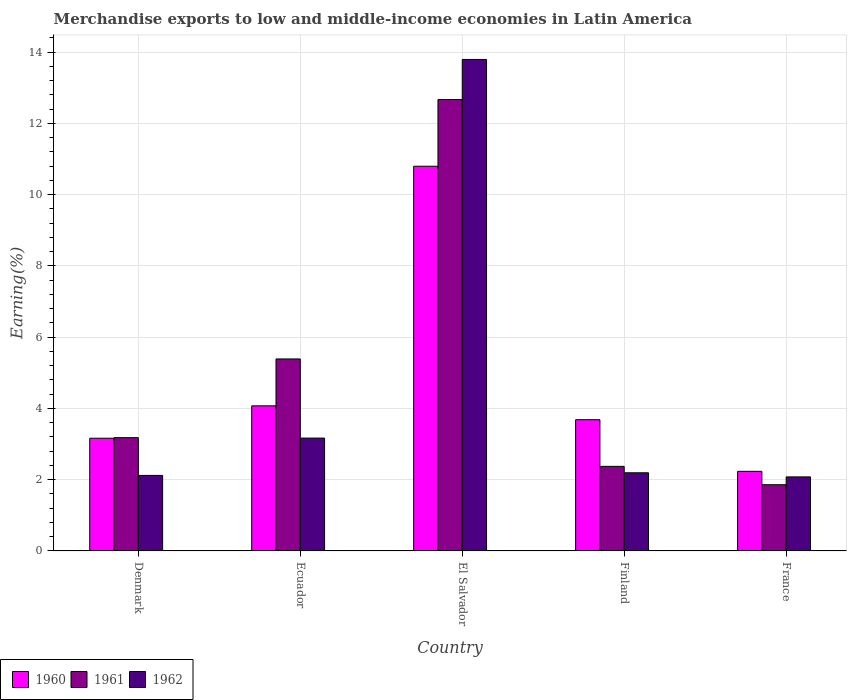Are the number of bars per tick equal to the number of legend labels?
Offer a terse response. Yes. Are the number of bars on each tick of the X-axis equal?
Your response must be concise. Yes. How many bars are there on the 1st tick from the right?
Provide a short and direct response. 3. What is the label of the 3rd group of bars from the left?
Your answer should be compact. El Salvador. What is the percentage of amount earned from merchandise exports in 1962 in France?
Provide a succinct answer. 2.08. Across all countries, what is the maximum percentage of amount earned from merchandise exports in 1961?
Ensure brevity in your answer.  12.67. Across all countries, what is the minimum percentage of amount earned from merchandise exports in 1960?
Make the answer very short. 2.23. In which country was the percentage of amount earned from merchandise exports in 1961 maximum?
Offer a very short reply. El Salvador. In which country was the percentage of amount earned from merchandise exports in 1960 minimum?
Your answer should be very brief. France. What is the total percentage of amount earned from merchandise exports in 1961 in the graph?
Ensure brevity in your answer.  25.47. What is the difference between the percentage of amount earned from merchandise exports in 1961 in Denmark and that in France?
Provide a succinct answer. 1.32. What is the difference between the percentage of amount earned from merchandise exports in 1960 in Finland and the percentage of amount earned from merchandise exports in 1961 in El Salvador?
Offer a very short reply. -8.98. What is the average percentage of amount earned from merchandise exports in 1960 per country?
Make the answer very short. 4.79. What is the difference between the percentage of amount earned from merchandise exports of/in 1960 and percentage of amount earned from merchandise exports of/in 1961 in Denmark?
Provide a short and direct response. -0.02. What is the ratio of the percentage of amount earned from merchandise exports in 1960 in Denmark to that in Ecuador?
Your answer should be compact. 0.78. Is the difference between the percentage of amount earned from merchandise exports in 1960 in El Salvador and Finland greater than the difference between the percentage of amount earned from merchandise exports in 1961 in El Salvador and Finland?
Offer a very short reply. No. What is the difference between the highest and the second highest percentage of amount earned from merchandise exports in 1962?
Your response must be concise. -0.97. What is the difference between the highest and the lowest percentage of amount earned from merchandise exports in 1962?
Provide a short and direct response. 11.71. Is it the case that in every country, the sum of the percentage of amount earned from merchandise exports in 1962 and percentage of amount earned from merchandise exports in 1961 is greater than the percentage of amount earned from merchandise exports in 1960?
Make the answer very short. Yes. How many bars are there?
Provide a short and direct response. 15. Are all the bars in the graph horizontal?
Your response must be concise. No. How many countries are there in the graph?
Keep it short and to the point. 5. Where does the legend appear in the graph?
Offer a very short reply. Bottom left. How many legend labels are there?
Your answer should be compact. 3. How are the legend labels stacked?
Keep it short and to the point. Horizontal. What is the title of the graph?
Make the answer very short. Merchandise exports to low and middle-income economies in Latin America. What is the label or title of the X-axis?
Provide a short and direct response. Country. What is the label or title of the Y-axis?
Make the answer very short. Earning(%). What is the Earning(%) in 1960 in Denmark?
Your answer should be very brief. 3.16. What is the Earning(%) of 1961 in Denmark?
Provide a succinct answer. 3.18. What is the Earning(%) in 1962 in Denmark?
Give a very brief answer. 2.12. What is the Earning(%) in 1960 in Ecuador?
Provide a succinct answer. 4.07. What is the Earning(%) in 1961 in Ecuador?
Provide a short and direct response. 5.39. What is the Earning(%) in 1962 in Ecuador?
Provide a succinct answer. 3.17. What is the Earning(%) in 1960 in El Salvador?
Offer a terse response. 10.8. What is the Earning(%) of 1961 in El Salvador?
Offer a terse response. 12.67. What is the Earning(%) of 1962 in El Salvador?
Provide a short and direct response. 13.79. What is the Earning(%) in 1960 in Finland?
Give a very brief answer. 3.68. What is the Earning(%) in 1961 in Finland?
Provide a succinct answer. 2.37. What is the Earning(%) in 1962 in Finland?
Make the answer very short. 2.19. What is the Earning(%) in 1960 in France?
Provide a succinct answer. 2.23. What is the Earning(%) of 1961 in France?
Offer a terse response. 1.86. What is the Earning(%) in 1962 in France?
Your answer should be compact. 2.08. Across all countries, what is the maximum Earning(%) of 1960?
Provide a short and direct response. 10.8. Across all countries, what is the maximum Earning(%) in 1961?
Your answer should be very brief. 12.67. Across all countries, what is the maximum Earning(%) of 1962?
Provide a succinct answer. 13.79. Across all countries, what is the minimum Earning(%) of 1960?
Ensure brevity in your answer.  2.23. Across all countries, what is the minimum Earning(%) in 1961?
Your response must be concise. 1.86. Across all countries, what is the minimum Earning(%) of 1962?
Keep it short and to the point. 2.08. What is the total Earning(%) of 1960 in the graph?
Make the answer very short. 23.95. What is the total Earning(%) of 1961 in the graph?
Your answer should be compact. 25.47. What is the total Earning(%) in 1962 in the graph?
Keep it short and to the point. 23.35. What is the difference between the Earning(%) of 1960 in Denmark and that in Ecuador?
Ensure brevity in your answer.  -0.91. What is the difference between the Earning(%) in 1961 in Denmark and that in Ecuador?
Offer a terse response. -2.21. What is the difference between the Earning(%) of 1962 in Denmark and that in Ecuador?
Make the answer very short. -1.05. What is the difference between the Earning(%) in 1960 in Denmark and that in El Salvador?
Make the answer very short. -7.63. What is the difference between the Earning(%) of 1961 in Denmark and that in El Salvador?
Offer a very short reply. -9.49. What is the difference between the Earning(%) of 1962 in Denmark and that in El Salvador?
Ensure brevity in your answer.  -11.67. What is the difference between the Earning(%) of 1960 in Denmark and that in Finland?
Offer a terse response. -0.52. What is the difference between the Earning(%) of 1961 in Denmark and that in Finland?
Keep it short and to the point. 0.81. What is the difference between the Earning(%) in 1962 in Denmark and that in Finland?
Your answer should be compact. -0.07. What is the difference between the Earning(%) in 1960 in Denmark and that in France?
Provide a succinct answer. 0.93. What is the difference between the Earning(%) in 1961 in Denmark and that in France?
Give a very brief answer. 1.32. What is the difference between the Earning(%) in 1962 in Denmark and that in France?
Offer a very short reply. 0.04. What is the difference between the Earning(%) in 1960 in Ecuador and that in El Salvador?
Offer a terse response. -6.72. What is the difference between the Earning(%) of 1961 in Ecuador and that in El Salvador?
Your response must be concise. -7.28. What is the difference between the Earning(%) of 1962 in Ecuador and that in El Salvador?
Your response must be concise. -10.63. What is the difference between the Earning(%) in 1960 in Ecuador and that in Finland?
Offer a very short reply. 0.39. What is the difference between the Earning(%) in 1961 in Ecuador and that in Finland?
Offer a terse response. 3.01. What is the difference between the Earning(%) in 1962 in Ecuador and that in Finland?
Offer a terse response. 0.97. What is the difference between the Earning(%) of 1960 in Ecuador and that in France?
Provide a succinct answer. 1.84. What is the difference between the Earning(%) in 1961 in Ecuador and that in France?
Offer a terse response. 3.53. What is the difference between the Earning(%) in 1962 in Ecuador and that in France?
Your response must be concise. 1.09. What is the difference between the Earning(%) in 1960 in El Salvador and that in Finland?
Offer a very short reply. 7.11. What is the difference between the Earning(%) in 1961 in El Salvador and that in Finland?
Ensure brevity in your answer.  10.29. What is the difference between the Earning(%) in 1962 in El Salvador and that in Finland?
Your answer should be compact. 11.6. What is the difference between the Earning(%) in 1960 in El Salvador and that in France?
Make the answer very short. 8.56. What is the difference between the Earning(%) in 1961 in El Salvador and that in France?
Offer a terse response. 10.81. What is the difference between the Earning(%) of 1962 in El Salvador and that in France?
Your answer should be very brief. 11.71. What is the difference between the Earning(%) of 1960 in Finland and that in France?
Provide a short and direct response. 1.45. What is the difference between the Earning(%) of 1961 in Finland and that in France?
Your answer should be compact. 0.51. What is the difference between the Earning(%) of 1962 in Finland and that in France?
Offer a very short reply. 0.12. What is the difference between the Earning(%) in 1960 in Denmark and the Earning(%) in 1961 in Ecuador?
Your response must be concise. -2.22. What is the difference between the Earning(%) in 1960 in Denmark and the Earning(%) in 1962 in Ecuador?
Offer a terse response. -0. What is the difference between the Earning(%) of 1961 in Denmark and the Earning(%) of 1962 in Ecuador?
Give a very brief answer. 0.01. What is the difference between the Earning(%) in 1960 in Denmark and the Earning(%) in 1961 in El Salvador?
Give a very brief answer. -9.5. What is the difference between the Earning(%) of 1960 in Denmark and the Earning(%) of 1962 in El Salvador?
Make the answer very short. -10.63. What is the difference between the Earning(%) of 1961 in Denmark and the Earning(%) of 1962 in El Salvador?
Your answer should be very brief. -10.61. What is the difference between the Earning(%) of 1960 in Denmark and the Earning(%) of 1961 in Finland?
Your answer should be compact. 0.79. What is the difference between the Earning(%) in 1960 in Denmark and the Earning(%) in 1962 in Finland?
Ensure brevity in your answer.  0.97. What is the difference between the Earning(%) in 1961 in Denmark and the Earning(%) in 1962 in Finland?
Provide a succinct answer. 0.99. What is the difference between the Earning(%) in 1960 in Denmark and the Earning(%) in 1961 in France?
Your answer should be compact. 1.3. What is the difference between the Earning(%) of 1960 in Denmark and the Earning(%) of 1962 in France?
Provide a short and direct response. 1.09. What is the difference between the Earning(%) in 1961 in Denmark and the Earning(%) in 1962 in France?
Provide a succinct answer. 1.1. What is the difference between the Earning(%) of 1960 in Ecuador and the Earning(%) of 1961 in El Salvador?
Your response must be concise. -8.59. What is the difference between the Earning(%) of 1960 in Ecuador and the Earning(%) of 1962 in El Salvador?
Offer a very short reply. -9.72. What is the difference between the Earning(%) in 1961 in Ecuador and the Earning(%) in 1962 in El Salvador?
Keep it short and to the point. -8.4. What is the difference between the Earning(%) of 1960 in Ecuador and the Earning(%) of 1961 in Finland?
Your response must be concise. 1.7. What is the difference between the Earning(%) of 1960 in Ecuador and the Earning(%) of 1962 in Finland?
Your response must be concise. 1.88. What is the difference between the Earning(%) in 1961 in Ecuador and the Earning(%) in 1962 in Finland?
Give a very brief answer. 3.19. What is the difference between the Earning(%) of 1960 in Ecuador and the Earning(%) of 1961 in France?
Make the answer very short. 2.21. What is the difference between the Earning(%) of 1960 in Ecuador and the Earning(%) of 1962 in France?
Keep it short and to the point. 1.99. What is the difference between the Earning(%) of 1961 in Ecuador and the Earning(%) of 1962 in France?
Your response must be concise. 3.31. What is the difference between the Earning(%) in 1960 in El Salvador and the Earning(%) in 1961 in Finland?
Your response must be concise. 8.42. What is the difference between the Earning(%) in 1960 in El Salvador and the Earning(%) in 1962 in Finland?
Provide a short and direct response. 8.6. What is the difference between the Earning(%) of 1961 in El Salvador and the Earning(%) of 1962 in Finland?
Offer a very short reply. 10.47. What is the difference between the Earning(%) of 1960 in El Salvador and the Earning(%) of 1961 in France?
Offer a very short reply. 8.94. What is the difference between the Earning(%) of 1960 in El Salvador and the Earning(%) of 1962 in France?
Provide a short and direct response. 8.72. What is the difference between the Earning(%) of 1961 in El Salvador and the Earning(%) of 1962 in France?
Your answer should be compact. 10.59. What is the difference between the Earning(%) of 1960 in Finland and the Earning(%) of 1961 in France?
Your response must be concise. 1.82. What is the difference between the Earning(%) in 1960 in Finland and the Earning(%) in 1962 in France?
Make the answer very short. 1.6. What is the difference between the Earning(%) in 1961 in Finland and the Earning(%) in 1962 in France?
Keep it short and to the point. 0.3. What is the average Earning(%) of 1960 per country?
Your answer should be very brief. 4.79. What is the average Earning(%) of 1961 per country?
Your answer should be very brief. 5.09. What is the average Earning(%) of 1962 per country?
Provide a succinct answer. 4.67. What is the difference between the Earning(%) of 1960 and Earning(%) of 1961 in Denmark?
Your answer should be very brief. -0.02. What is the difference between the Earning(%) of 1960 and Earning(%) of 1962 in Denmark?
Your response must be concise. 1.04. What is the difference between the Earning(%) in 1961 and Earning(%) in 1962 in Denmark?
Your answer should be very brief. 1.06. What is the difference between the Earning(%) of 1960 and Earning(%) of 1961 in Ecuador?
Give a very brief answer. -1.32. What is the difference between the Earning(%) in 1960 and Earning(%) in 1962 in Ecuador?
Your response must be concise. 0.91. What is the difference between the Earning(%) in 1961 and Earning(%) in 1962 in Ecuador?
Offer a terse response. 2.22. What is the difference between the Earning(%) of 1960 and Earning(%) of 1961 in El Salvador?
Your response must be concise. -1.87. What is the difference between the Earning(%) of 1960 and Earning(%) of 1962 in El Salvador?
Your response must be concise. -3. What is the difference between the Earning(%) in 1961 and Earning(%) in 1962 in El Salvador?
Keep it short and to the point. -1.13. What is the difference between the Earning(%) in 1960 and Earning(%) in 1961 in Finland?
Your response must be concise. 1.31. What is the difference between the Earning(%) in 1960 and Earning(%) in 1962 in Finland?
Give a very brief answer. 1.49. What is the difference between the Earning(%) of 1961 and Earning(%) of 1962 in Finland?
Offer a terse response. 0.18. What is the difference between the Earning(%) of 1960 and Earning(%) of 1961 in France?
Provide a succinct answer. 0.38. What is the difference between the Earning(%) in 1960 and Earning(%) in 1962 in France?
Offer a very short reply. 0.16. What is the difference between the Earning(%) in 1961 and Earning(%) in 1962 in France?
Give a very brief answer. -0.22. What is the ratio of the Earning(%) of 1960 in Denmark to that in Ecuador?
Keep it short and to the point. 0.78. What is the ratio of the Earning(%) of 1961 in Denmark to that in Ecuador?
Your answer should be very brief. 0.59. What is the ratio of the Earning(%) of 1962 in Denmark to that in Ecuador?
Offer a terse response. 0.67. What is the ratio of the Earning(%) of 1960 in Denmark to that in El Salvador?
Provide a succinct answer. 0.29. What is the ratio of the Earning(%) of 1961 in Denmark to that in El Salvador?
Give a very brief answer. 0.25. What is the ratio of the Earning(%) in 1962 in Denmark to that in El Salvador?
Your answer should be compact. 0.15. What is the ratio of the Earning(%) in 1960 in Denmark to that in Finland?
Offer a very short reply. 0.86. What is the ratio of the Earning(%) of 1961 in Denmark to that in Finland?
Offer a terse response. 1.34. What is the ratio of the Earning(%) in 1962 in Denmark to that in Finland?
Your answer should be very brief. 0.97. What is the ratio of the Earning(%) in 1960 in Denmark to that in France?
Your response must be concise. 1.42. What is the ratio of the Earning(%) in 1961 in Denmark to that in France?
Provide a short and direct response. 1.71. What is the ratio of the Earning(%) of 1960 in Ecuador to that in El Salvador?
Your answer should be very brief. 0.38. What is the ratio of the Earning(%) of 1961 in Ecuador to that in El Salvador?
Your answer should be compact. 0.43. What is the ratio of the Earning(%) in 1962 in Ecuador to that in El Salvador?
Ensure brevity in your answer.  0.23. What is the ratio of the Earning(%) of 1960 in Ecuador to that in Finland?
Provide a short and direct response. 1.11. What is the ratio of the Earning(%) of 1961 in Ecuador to that in Finland?
Offer a very short reply. 2.27. What is the ratio of the Earning(%) in 1962 in Ecuador to that in Finland?
Offer a terse response. 1.44. What is the ratio of the Earning(%) of 1960 in Ecuador to that in France?
Ensure brevity in your answer.  1.82. What is the ratio of the Earning(%) of 1961 in Ecuador to that in France?
Offer a terse response. 2.9. What is the ratio of the Earning(%) of 1962 in Ecuador to that in France?
Give a very brief answer. 1.52. What is the ratio of the Earning(%) in 1960 in El Salvador to that in Finland?
Provide a succinct answer. 2.93. What is the ratio of the Earning(%) of 1961 in El Salvador to that in Finland?
Your response must be concise. 5.34. What is the ratio of the Earning(%) in 1962 in El Salvador to that in Finland?
Offer a very short reply. 6.29. What is the ratio of the Earning(%) in 1960 in El Salvador to that in France?
Your answer should be compact. 4.83. What is the ratio of the Earning(%) of 1961 in El Salvador to that in France?
Your answer should be compact. 6.81. What is the ratio of the Earning(%) in 1962 in El Salvador to that in France?
Your answer should be very brief. 6.63. What is the ratio of the Earning(%) in 1960 in Finland to that in France?
Your response must be concise. 1.65. What is the ratio of the Earning(%) of 1961 in Finland to that in France?
Your answer should be very brief. 1.28. What is the ratio of the Earning(%) in 1962 in Finland to that in France?
Your response must be concise. 1.06. What is the difference between the highest and the second highest Earning(%) in 1960?
Offer a very short reply. 6.72. What is the difference between the highest and the second highest Earning(%) in 1961?
Provide a short and direct response. 7.28. What is the difference between the highest and the second highest Earning(%) of 1962?
Keep it short and to the point. 10.63. What is the difference between the highest and the lowest Earning(%) of 1960?
Offer a very short reply. 8.56. What is the difference between the highest and the lowest Earning(%) of 1961?
Give a very brief answer. 10.81. What is the difference between the highest and the lowest Earning(%) in 1962?
Your answer should be compact. 11.71. 